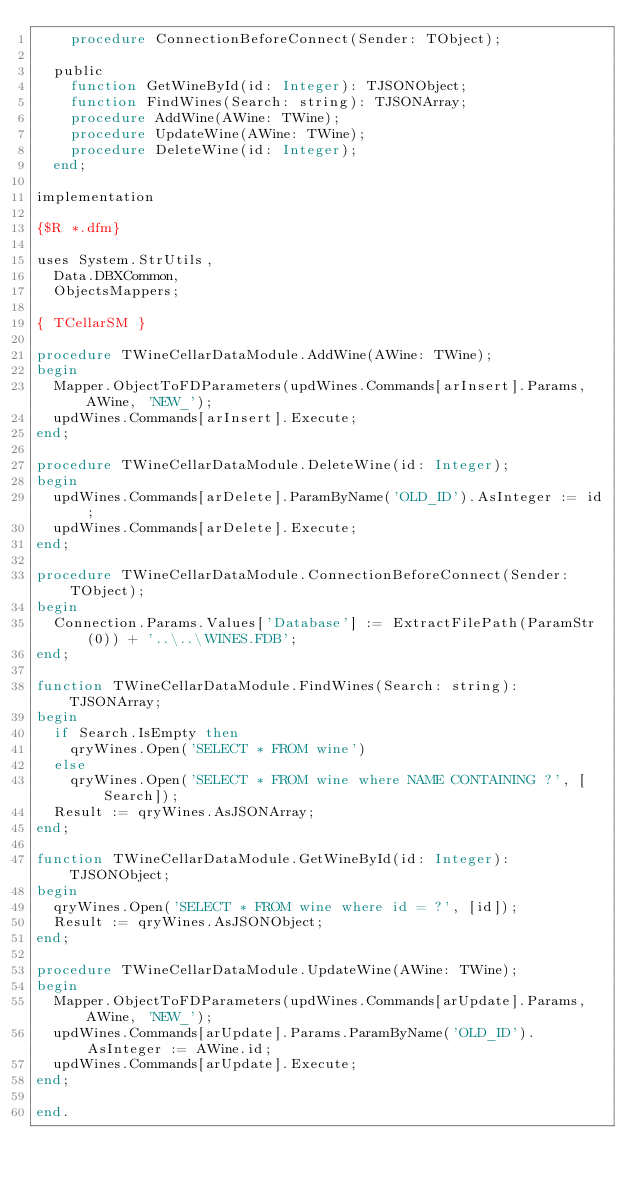Convert code to text. <code><loc_0><loc_0><loc_500><loc_500><_Pascal_>    procedure ConnectionBeforeConnect(Sender: TObject);

  public
    function GetWineById(id: Integer): TJSONObject;
    function FindWines(Search: string): TJSONArray;
    procedure AddWine(AWine: TWine);
    procedure UpdateWine(AWine: TWine);
    procedure DeleteWine(id: Integer);
  end;

implementation

{$R *.dfm}

uses System.StrUtils,
  Data.DBXCommon,
  ObjectsMappers;

{ TCellarSM }

procedure TWineCellarDataModule.AddWine(AWine: TWine);
begin
  Mapper.ObjectToFDParameters(updWines.Commands[arInsert].Params, AWine, 'NEW_');
  updWines.Commands[arInsert].Execute;
end;

procedure TWineCellarDataModule.DeleteWine(id: Integer);
begin
  updWines.Commands[arDelete].ParamByName('OLD_ID').AsInteger := id;
  updWines.Commands[arDelete].Execute;
end;

procedure TWineCellarDataModule.ConnectionBeforeConnect(Sender: TObject);
begin
  Connection.Params.Values['Database'] := ExtractFilePath(ParamStr(0)) + '..\..\WINES.FDB';
end;

function TWineCellarDataModule.FindWines(Search: string): TJSONArray;
begin
  if Search.IsEmpty then
    qryWines.Open('SELECT * FROM wine')
  else
    qryWines.Open('SELECT * FROM wine where NAME CONTAINING ?', [Search]);
  Result := qryWines.AsJSONArray;
end;

function TWineCellarDataModule.GetWineById(id: Integer): TJSONObject;
begin
  qryWines.Open('SELECT * FROM wine where id = ?', [id]);
  Result := qryWines.AsJSONObject;
end;

procedure TWineCellarDataModule.UpdateWine(AWine: TWine);
begin
  Mapper.ObjectToFDParameters(updWines.Commands[arUpdate].Params, AWine, 'NEW_');
  updWines.Commands[arUpdate].Params.ParamByName('OLD_ID').AsInteger := AWine.id;
  updWines.Commands[arUpdate].Execute;
end;

end.
</code> 